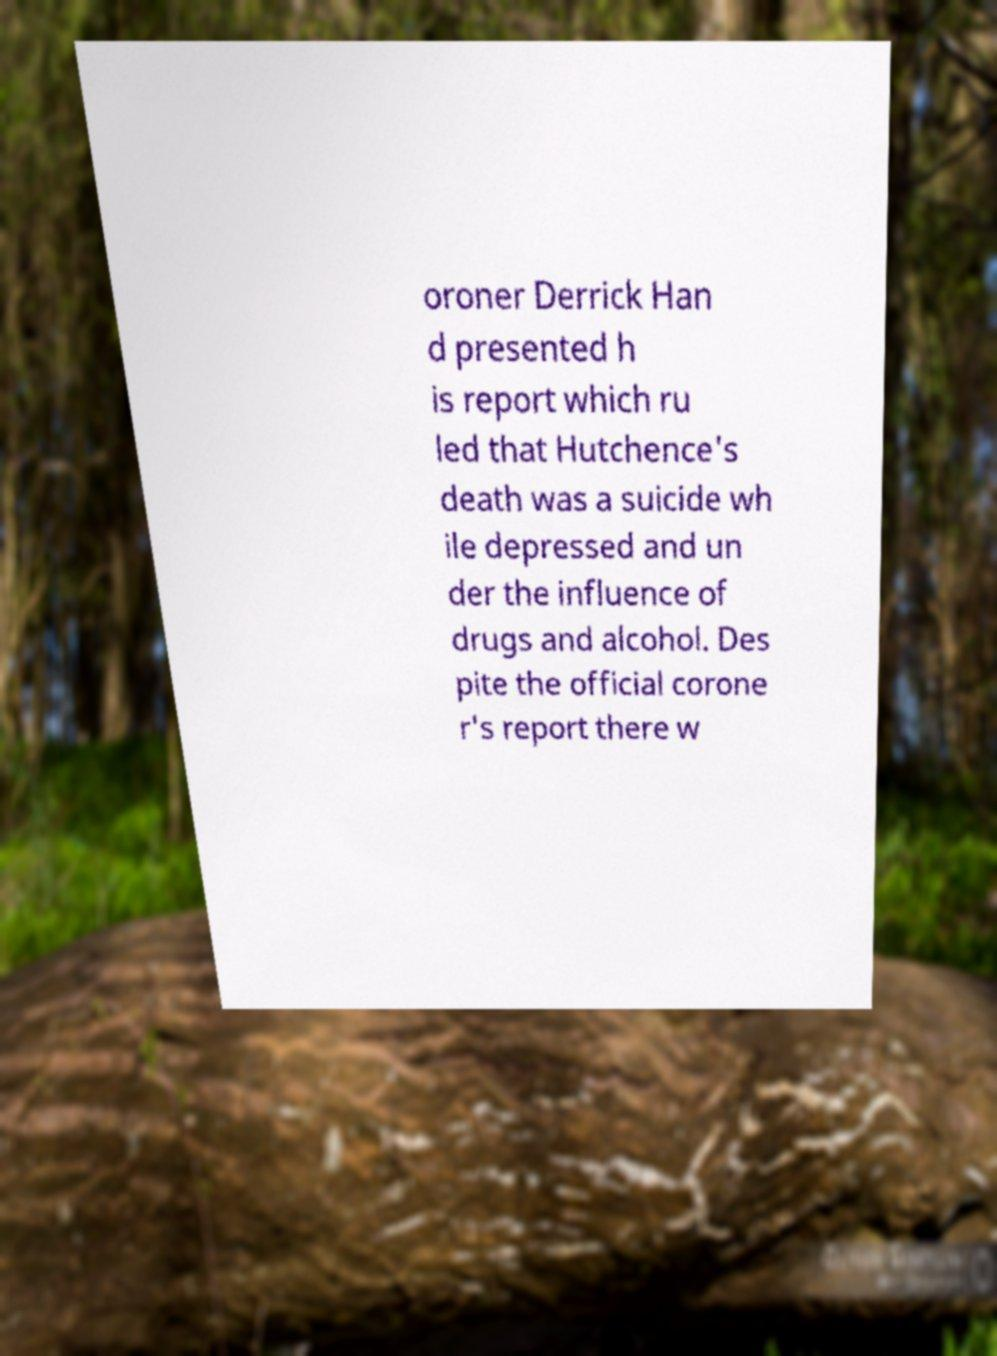Can you accurately transcribe the text from the provided image for me? oroner Derrick Han d presented h is report which ru led that Hutchence's death was a suicide wh ile depressed and un der the influence of drugs and alcohol. Des pite the official corone r's report there w 